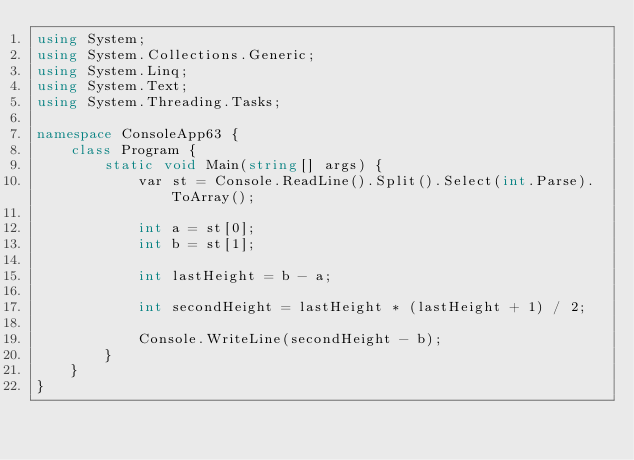Convert code to text. <code><loc_0><loc_0><loc_500><loc_500><_C#_>using System;
using System.Collections.Generic;
using System.Linq;
using System.Text;
using System.Threading.Tasks;

namespace ConsoleApp63 {
    class Program {
        static void Main(string[] args) {
            var st = Console.ReadLine().Split().Select(int.Parse).ToArray();

            int a = st[0];
            int b = st[1];

            int lastHeight = b - a;

            int secondHeight = lastHeight * (lastHeight + 1) / 2;

            Console.WriteLine(secondHeight - b);
        }
    }
}
</code> 